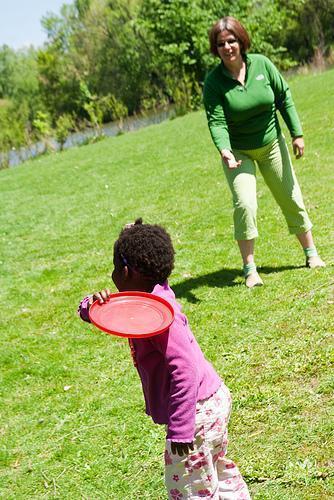How many people in photo?
Give a very brief answer. 2. 